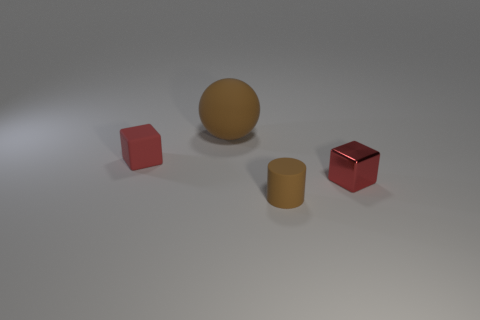Is the rubber ball the same color as the metallic thing?
Give a very brief answer. No. How many cubes are the same color as the tiny rubber cylinder?
Your response must be concise. 0. What is the color of the matte object that is in front of the tiny cube that is right of the tiny red block to the left of the tiny brown object?
Your response must be concise. Brown. The cube that is the same material as the brown ball is what color?
Your response must be concise. Red. There is a small thing that is to the left of the large ball; is it the same color as the matte sphere?
Your answer should be very brief. No. Is the number of small matte objects in front of the small matte block the same as the number of brown rubber balls?
Provide a succinct answer. Yes. What color is the rubber cylinder that is the same size as the metallic object?
Your answer should be very brief. Brown. Are there any large rubber objects that have the same shape as the small red metallic object?
Your answer should be compact. No. What is the material of the red cube that is on the left side of the matte object that is in front of the block behind the small shiny block?
Make the answer very short. Rubber. What number of other objects are the same size as the rubber sphere?
Ensure brevity in your answer.  0. 